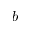<formula> <loc_0><loc_0><loc_500><loc_500>b</formula> 